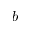<formula> <loc_0><loc_0><loc_500><loc_500>b</formula> 